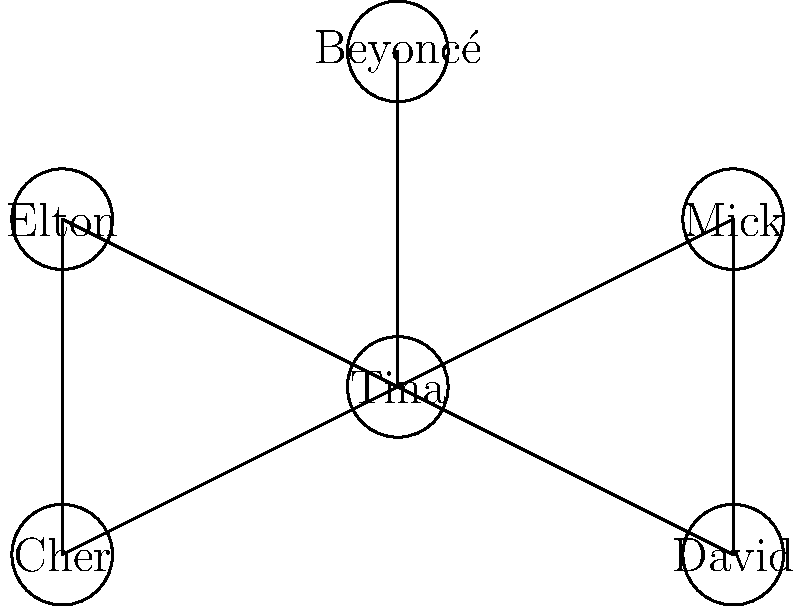In the collaboration network of Tina Turner shown above, what is the minimum number of collaborations that need to be removed to disconnect Tina from all other artists? To solve this problem, we need to analyze the connectivity of Tina Turner in the collaboration network:

1. Observe that Tina Turner (labeled as "Tina") is directly connected to 5 other artists: Mick, David, Elton, Cher, and Beyoncé.

2. Each of these connections represents a collaboration between Tina and the respective artist.

3. To disconnect Tina from all other artists, we need to remove all of her direct connections.

4. Counting the number of edges connected to Tina, we find that there are 5 such edges.

5. Removing any fewer than 5 edges would still leave Tina connected to at least one other artist.

Therefore, the minimum number of collaborations that need to be removed to disconnect Tina from all other artists is 5.
Answer: 5 